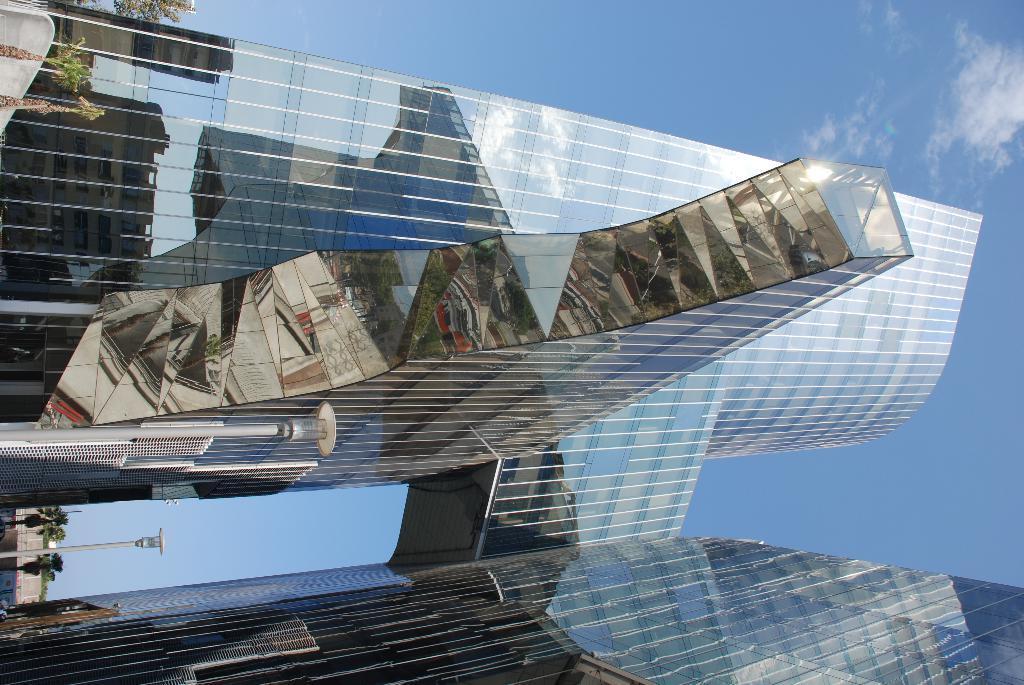Describe this image in one or two sentences. In this image, we can see buildings, trees, poles and at the top, there are clouds in the sky. 